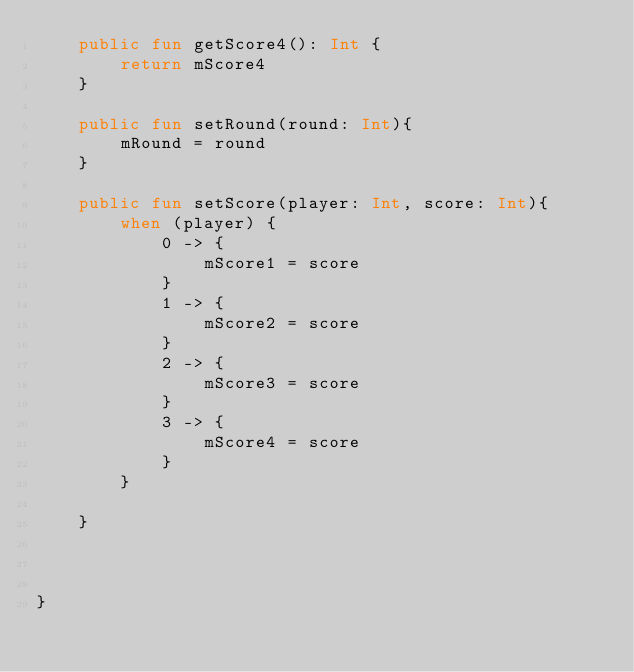<code> <loc_0><loc_0><loc_500><loc_500><_Kotlin_>    public fun getScore4(): Int {
        return mScore4
    }

    public fun setRound(round: Int){
        mRound = round
    }

    public fun setScore(player: Int, score: Int){
        when (player) {
            0 -> {
                mScore1 = score
            }
            1 -> {
                mScore2 = score
            }
            2 -> {
                mScore3 = score
            }
            3 -> {
                mScore4 = score
            }
        }

    }



}</code> 